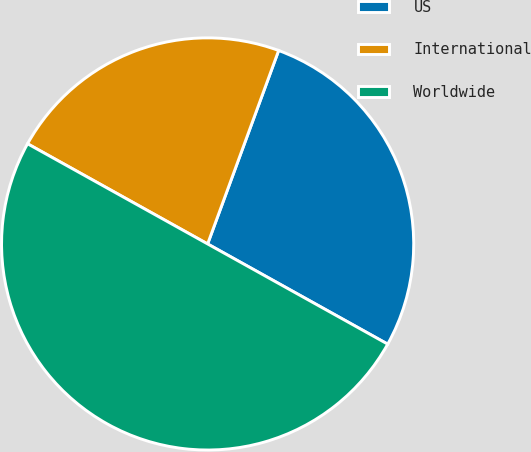<chart> <loc_0><loc_0><loc_500><loc_500><pie_chart><fcel>US<fcel>International<fcel>Worldwide<nl><fcel>27.48%<fcel>22.52%<fcel>50.0%<nl></chart> 